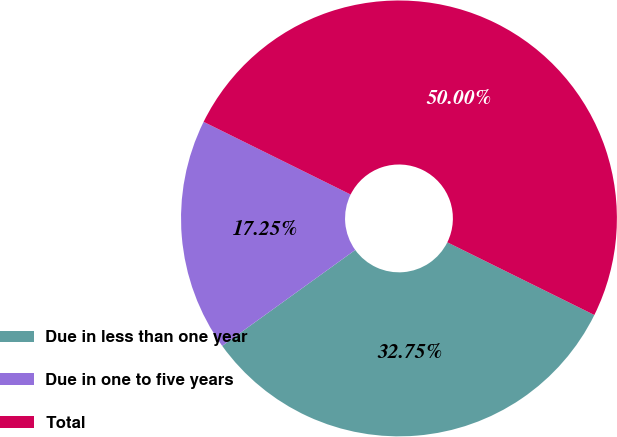Convert chart to OTSL. <chart><loc_0><loc_0><loc_500><loc_500><pie_chart><fcel>Due in less than one year<fcel>Due in one to five years<fcel>Total<nl><fcel>32.75%<fcel>17.25%<fcel>50.0%<nl></chart> 